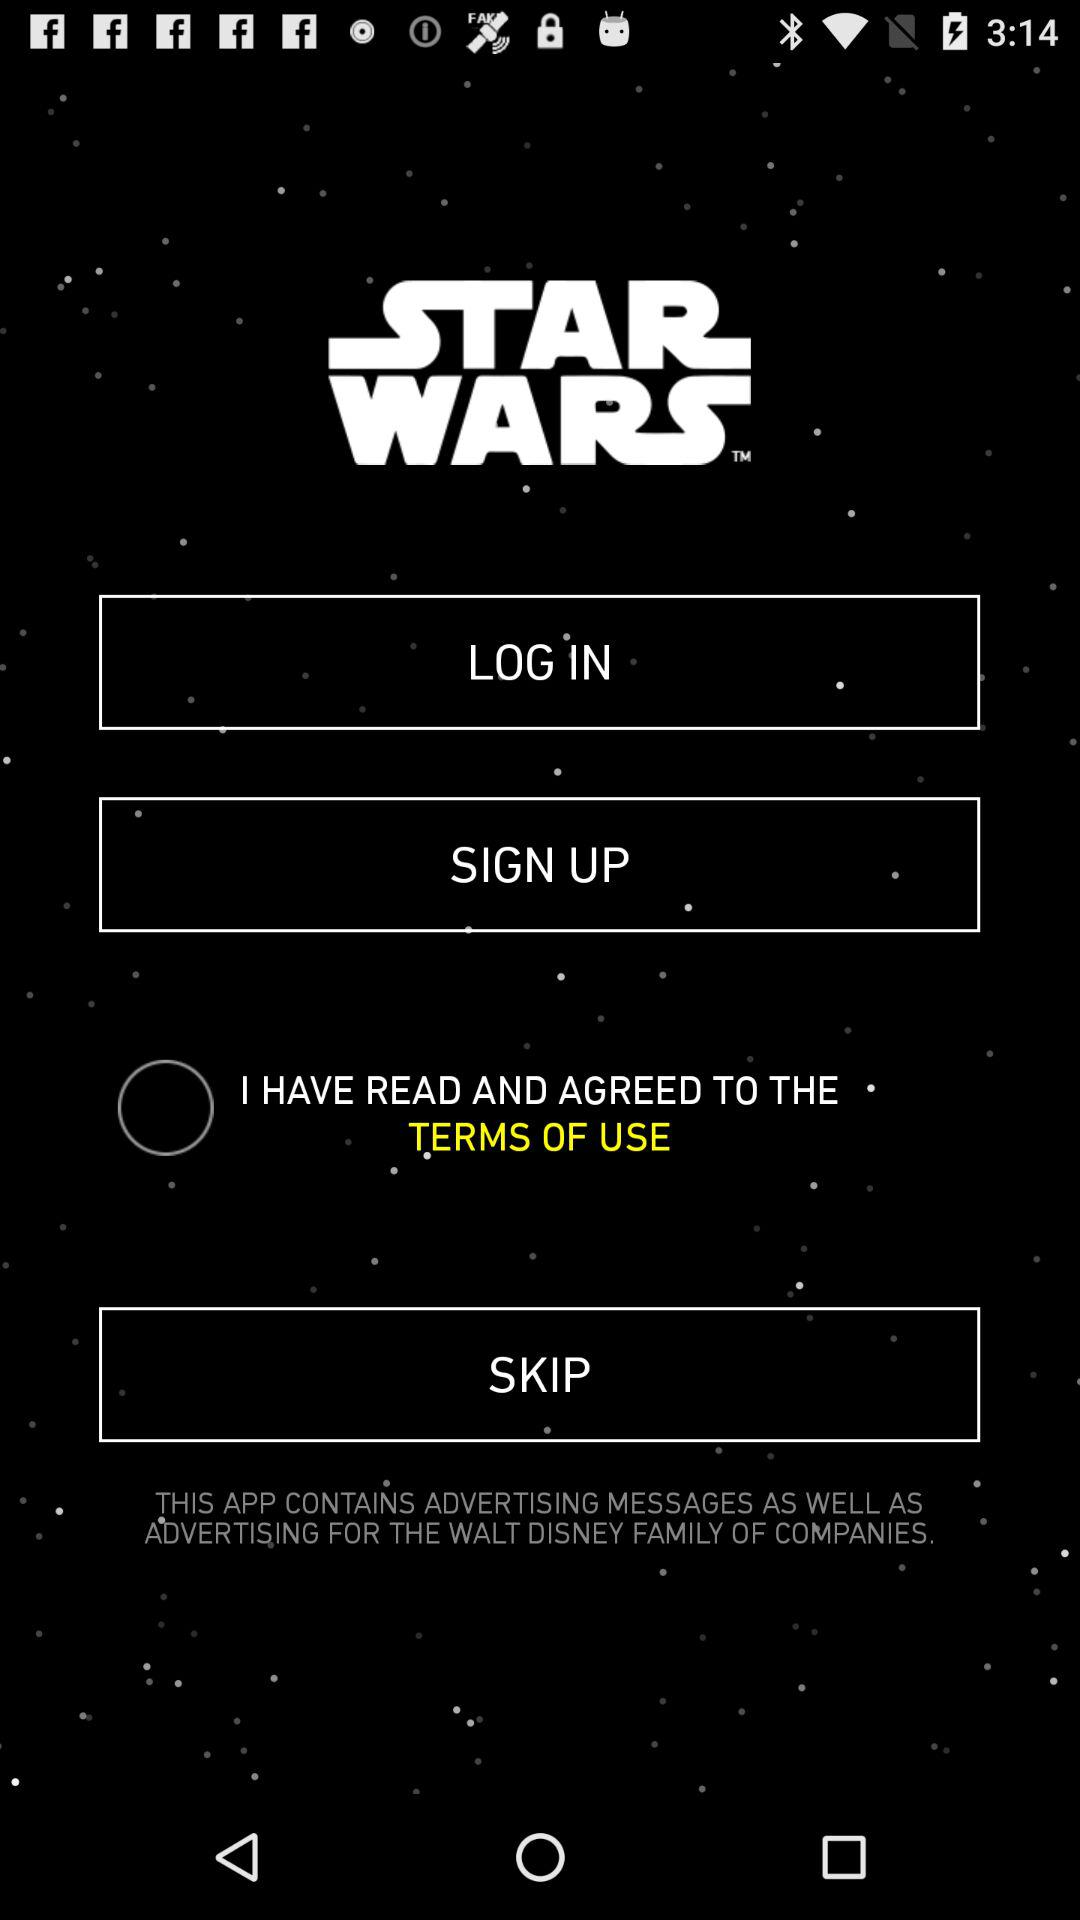What is the status of the option that includes agreement to the “TERMS OF USE"? The status is "off". 